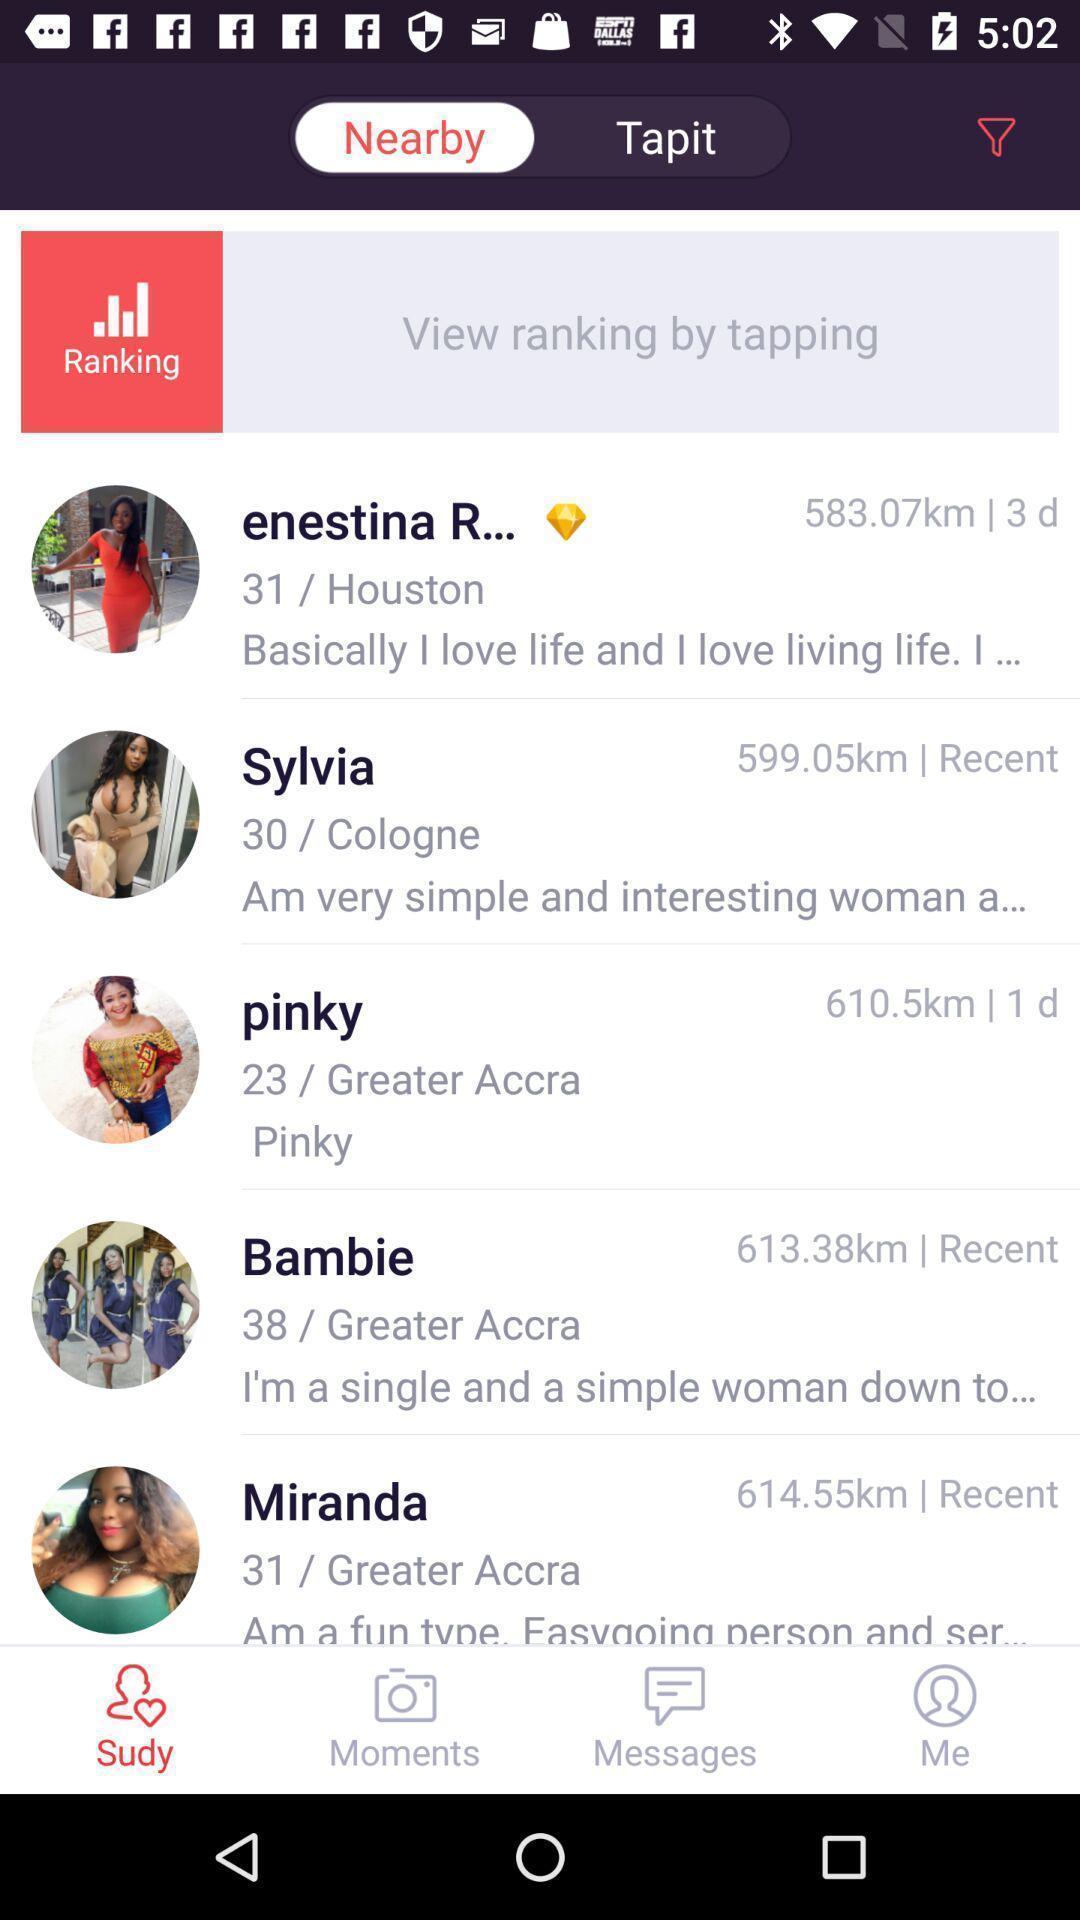Explain the elements present in this screenshot. Page showing the social app. 